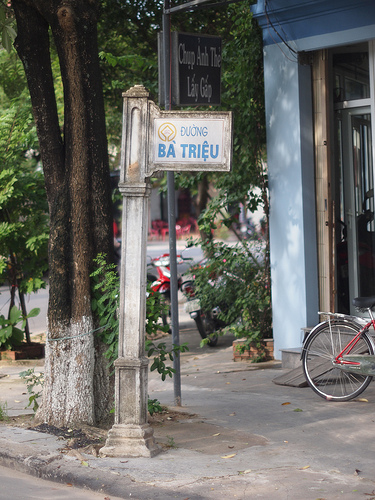Please provide the bounding box coordinate of the region this sentence describes: A building in the photo. The coordinates for the bounding box around the region described as 'a building in the photo' are approximately [0.67, 0.25, 0.77, 0.57]. 